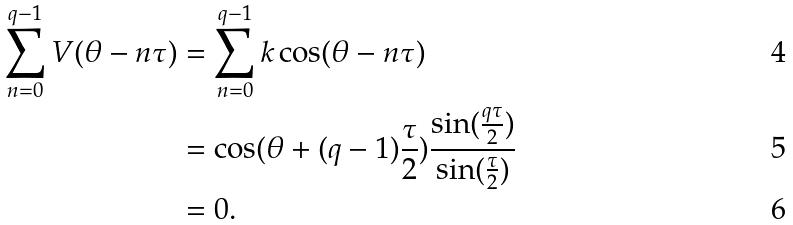<formula> <loc_0><loc_0><loc_500><loc_500>\sum _ { n = 0 } ^ { q - 1 } V ( \theta - n \tau ) & = \sum _ { n = 0 } ^ { q - 1 } k \cos ( \theta - n \tau ) \\ & = \cos ( \theta + ( q - 1 ) \frac { \tau } { 2 } ) \frac { \sin ( \frac { q \tau } { 2 } ) } { \sin ( \frac { \tau } { 2 } ) } \\ & = 0 .</formula> 